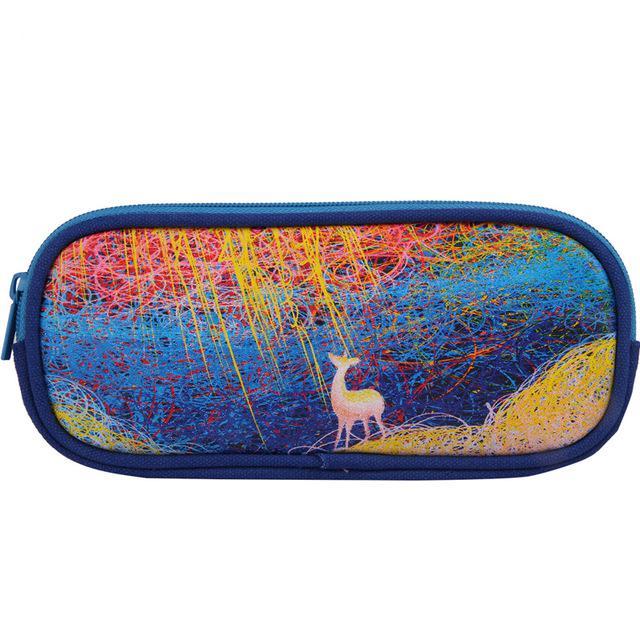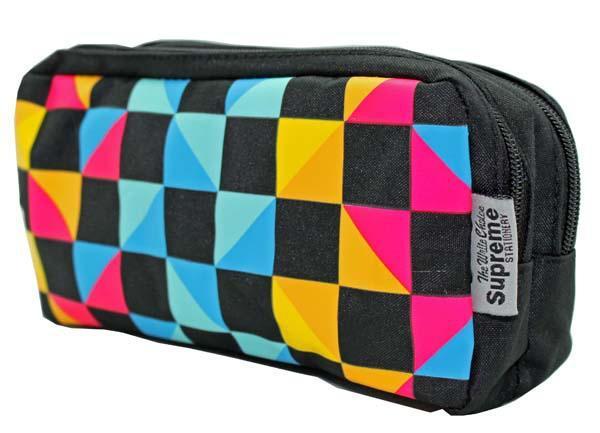The first image is the image on the left, the second image is the image on the right. Given the left and right images, does the statement "The left image shows an overlapping, upright row of at least three color versions of a pencil case style." hold true? Answer yes or no. No. 